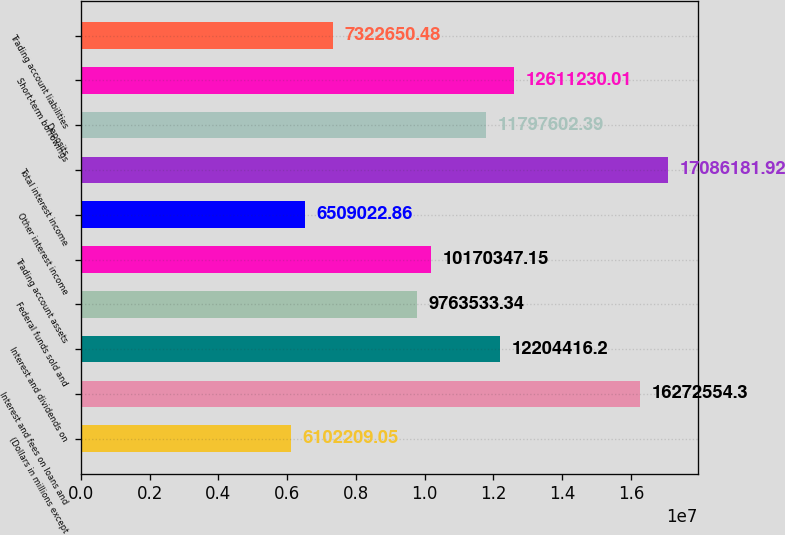Convert chart. <chart><loc_0><loc_0><loc_500><loc_500><bar_chart><fcel>(Dollars in millions except<fcel>Interest and fees on loans and<fcel>Interest and dividends on<fcel>Federal funds sold and<fcel>Trading account assets<fcel>Other interest income<fcel>Total interest income<fcel>Deposits<fcel>Short-term borrowings<fcel>Trading account liabilities<nl><fcel>6.10221e+06<fcel>1.62726e+07<fcel>1.22044e+07<fcel>9.76353e+06<fcel>1.01703e+07<fcel>6.50902e+06<fcel>1.70862e+07<fcel>1.17976e+07<fcel>1.26112e+07<fcel>7.32265e+06<nl></chart> 